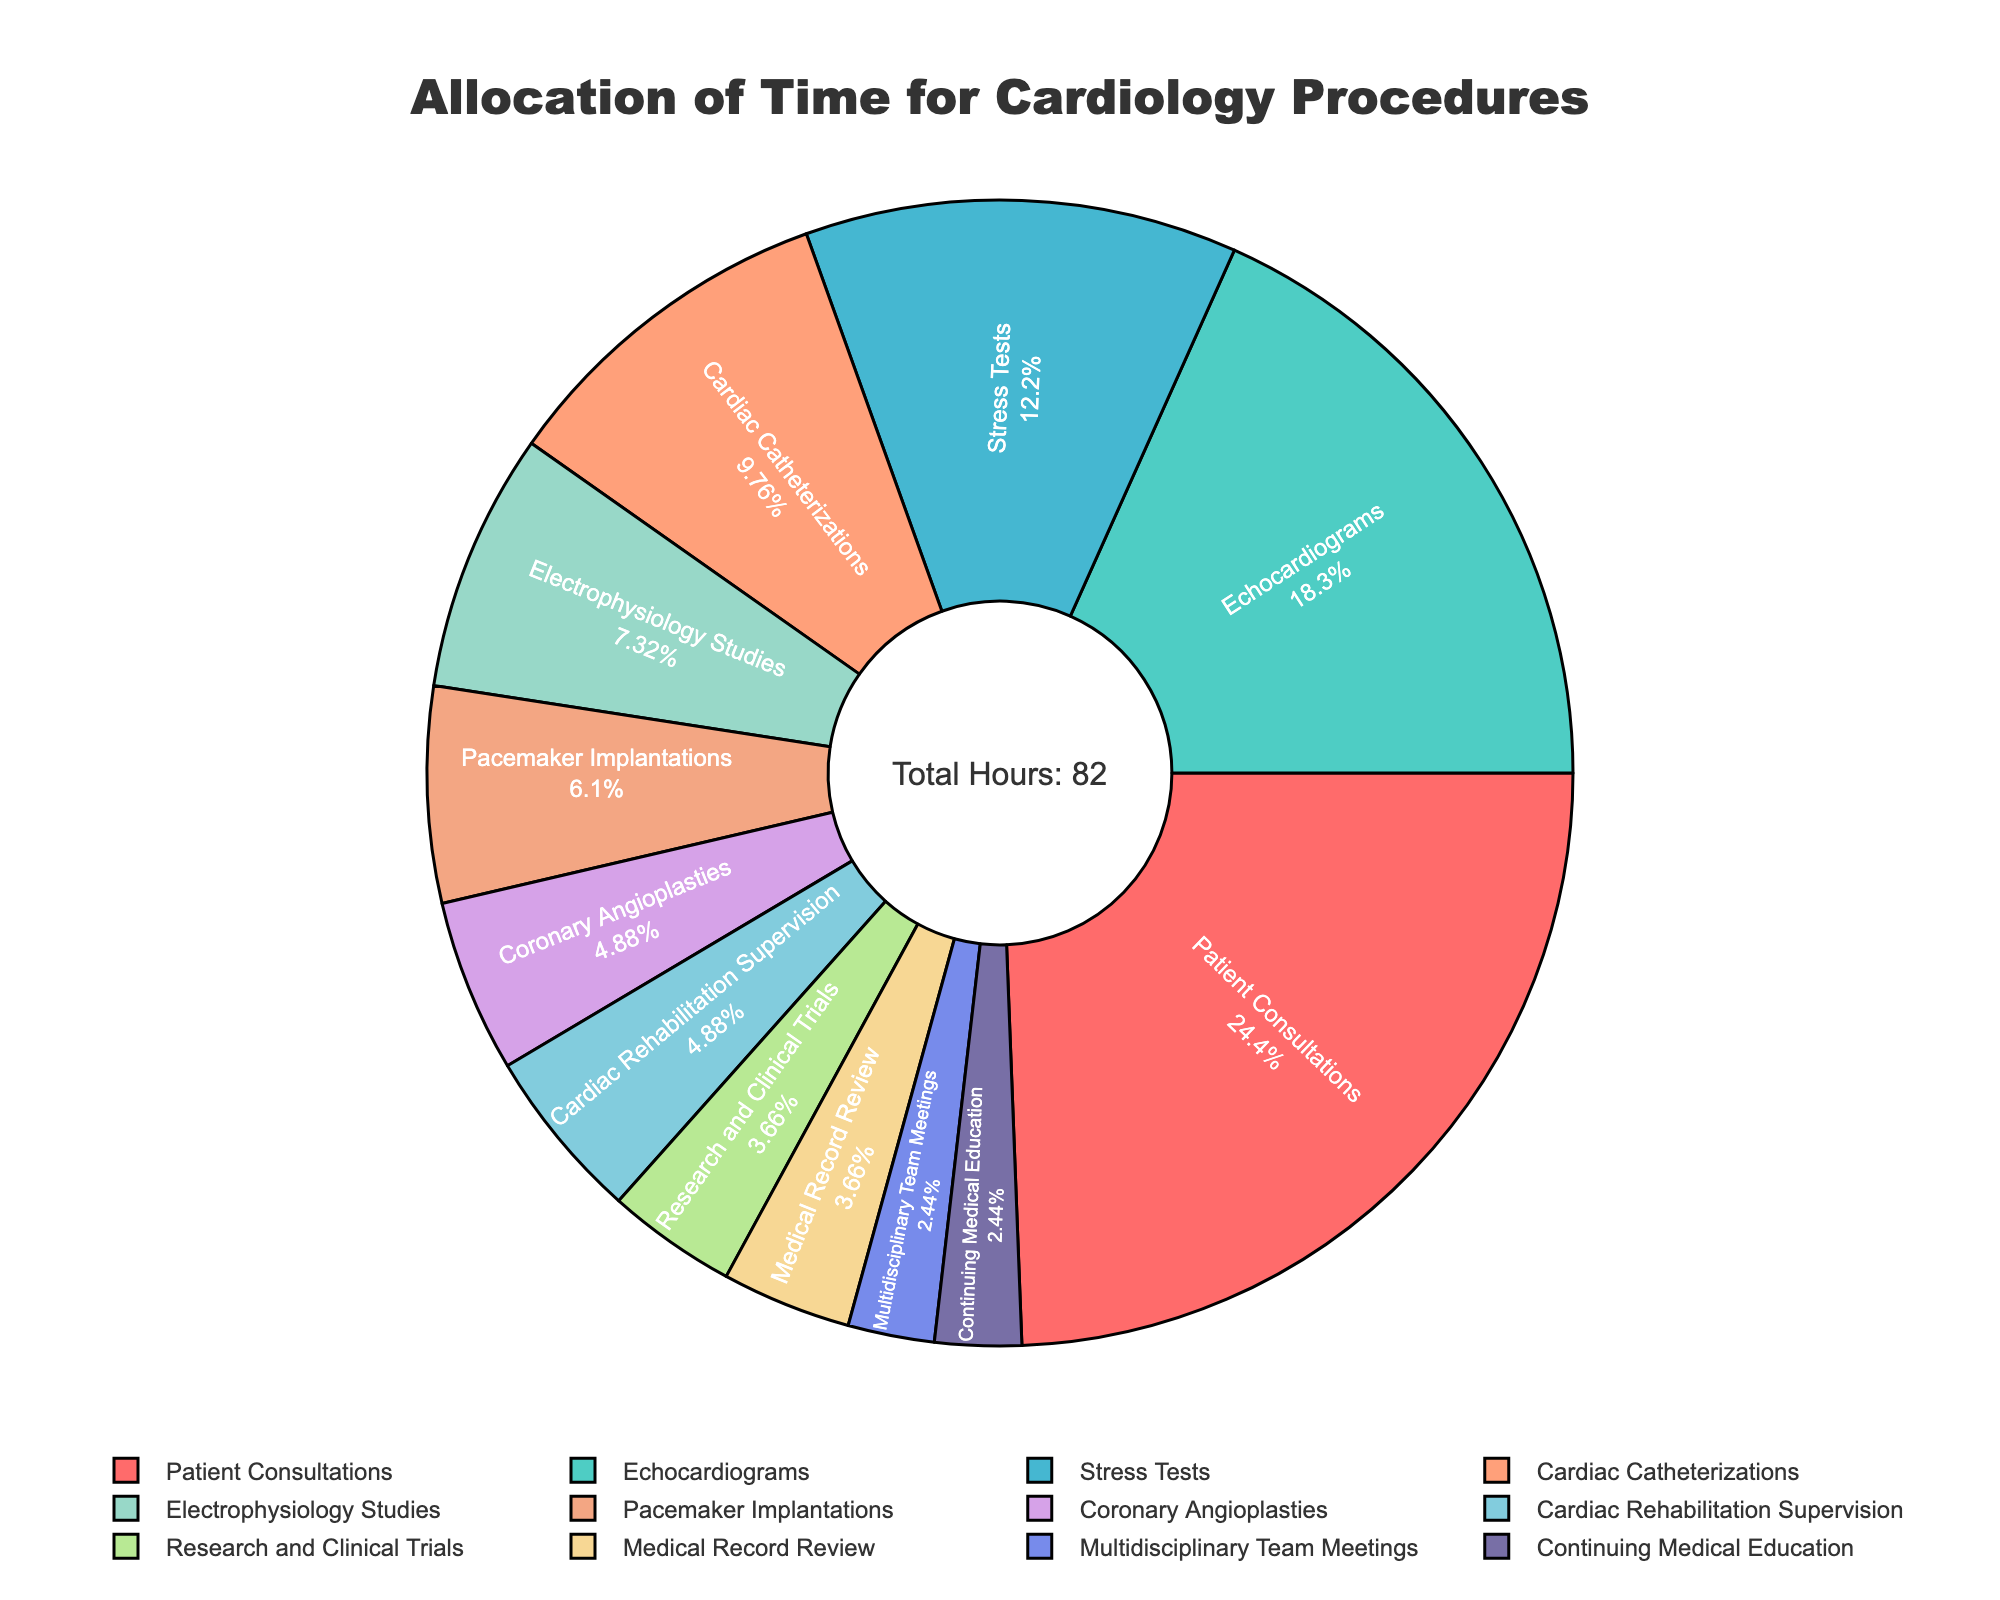Which procedure consumes the most hours during the week? The procedure segment with the largest area in the pie chart represents the one with the most hours. Patient Consultations take up the largest area, indicating they consume the most hours.
Answer: Patient Consultations How much time is spent on Patient Consultations and Echocardiograms combined? The hours for Patient Consultations and Echocardiograms are listed as 20 and 15, respectively. Summing these values gives 20 + 15 = 35 hours.
Answer: 35 hours What is the percentage of time allocated to Medical Record Review? The Medical Record Review segment in the pie chart shows its percentage. This segment accounts for 3 hours out of the total 82 hours. The percentage is calculated as (3/82) * 100.
Answer: Approximately 3.66% Which procedures take up less than 5% of the total time each? We identify segments in the pie chart that represent less than 5% of the pie. Procedures with small segments and low values include Cardiac Rehabilitation Supervision, Research and Clinical Trials, Medical Record Review, Multidisciplinary Team Meetings, and Continuing Medical Education.
Answer: Cardiac Rehabilitation Supervision, Research and Clinical Trials, Medical Record Review, Multidisciplinary Team Meetings, Continuing Medical Education What procedures require more hours than Cardiac Catheterizations but less than Stress Tests? We compare the number of hours from the pie chart where Stress Tests have 10 hours and Cardiac Catheterizations have 8 hours. Echocardiograms fall within this range.
Answer: Echocardiograms What's the total time allocated to Cardiac Catheterizations, Electrophysiology Studies, and Pacemaker Implantations? We add the hours spent on Cardiac Catheterizations (8), Electrophysiology Studies (6), and Pacemaker Implantations (5) from the pie chart. The sum is 8 + 6 + 5 = 19 hours.
Answer: 19 hours Is the time spent on Electrophysiology Studies greater than the time spent on Coronary Angioplasties? We compare the number of hours for Electrophysiology Studies (6) and Coronary Angioplasties (4) as shown in the pie chart. 6 is greater than 4.
Answer: Yes Which procedures consume less time than Pacemaker Implantations? Procedures with segments corresponding to fewer hours than Pacemaker Implantations (5 hours) are identified. These include Coronary Angioplasties, Cardiac Rehabilitation Supervision, Research and Clinical Trials, Medical Record Review, Multidisciplinary Team Meetings, and Continuing Medical Education.
Answer: Coronary Angioplasties, Cardiac Rehabilitation Supervision, Research and Clinical Trials, Medical Record Review, Multidisciplinary Team Meetings, Continuing Medical Education 